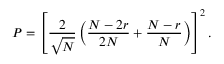Convert formula to latex. <formula><loc_0><loc_0><loc_500><loc_500>P = \left [ \frac { 2 } { \sqrt { N } } \left ( \frac { N - 2 r } { 2 N } + \frac { N - r } { N } \right ) \right ] ^ { 2 } .</formula> 